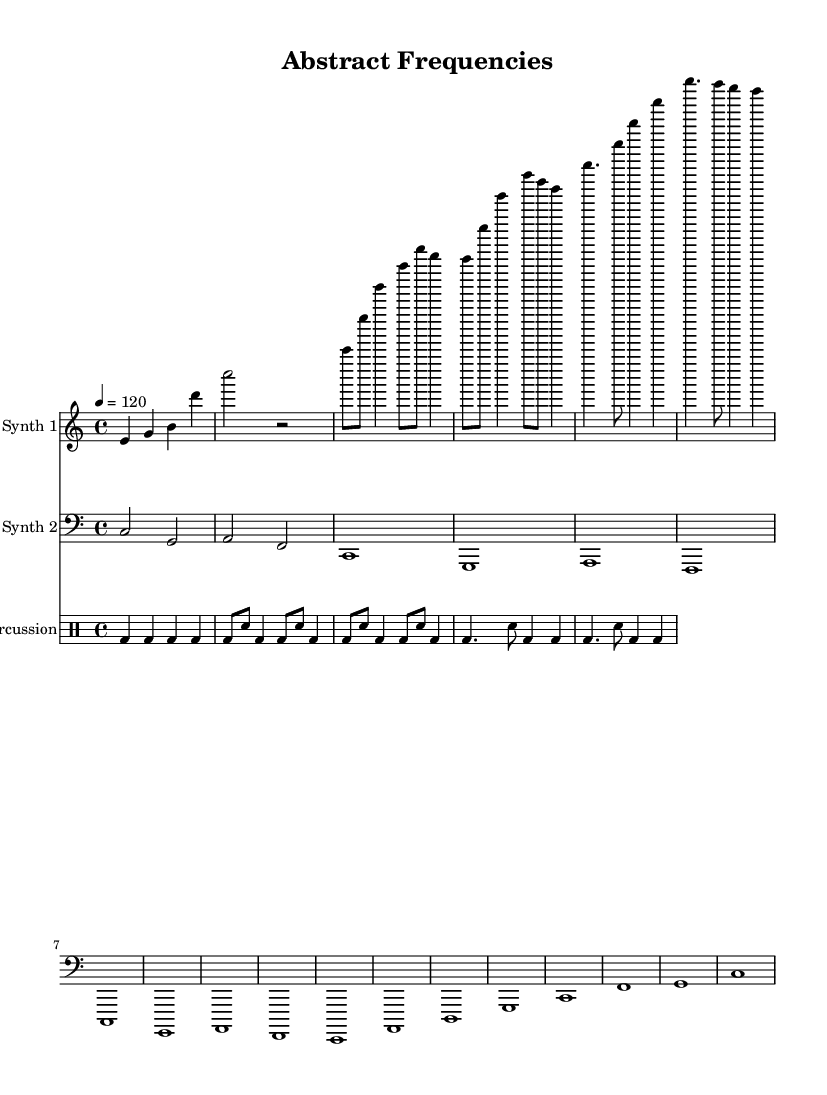What is the key signature of this music? The key signature is C major. This is determined by the absence of any sharps or flats indicated at the beginning of the staff.
Answer: C major What is the time signature of this piece? The time signature is 4/4, which is displayed at the beginning of the score. This means there are four beats in a measure, and the quarter note gets one beat.
Answer: 4/4 What is the tempo marking? The tempo marking is 120 beats per minute, indicated by the text "4 = 120" at the beginning of the global settings.
Answer: 120 How many measures are in Synth 1? Synth 1 has a total of 6 measures, as counted from the beginning to the end of the provided music notation for Synth 1.
Answer: 6 What type of instrument is represented by Synth 2? Synth 2 is represented as a bass synth, denoted by the clef used (bass clef), which indicates lower pitch sounds typical of synthesizers in that range.
Answer: Bass synth How is the digital percussion pattern structured? The digital percussion pattern consists of a series of bass drum and snare hits, with variations in rhythm indicated by their different durations and counts in the measures.
Answer: Bass drum and snare 